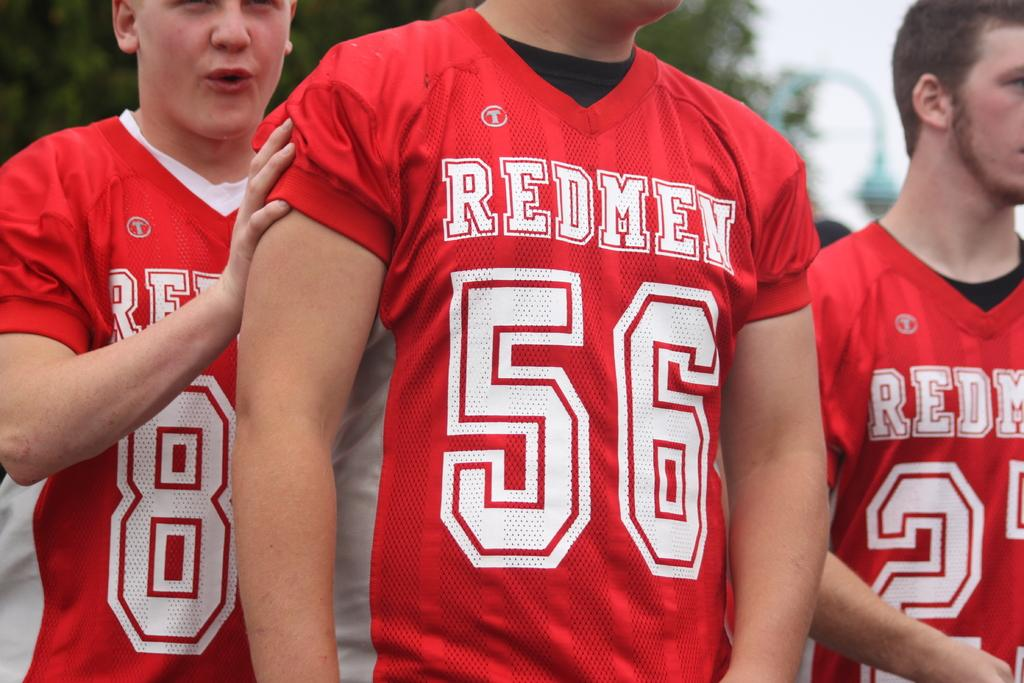<image>
Describe the image concisely. The jersey with the number 56 on it 